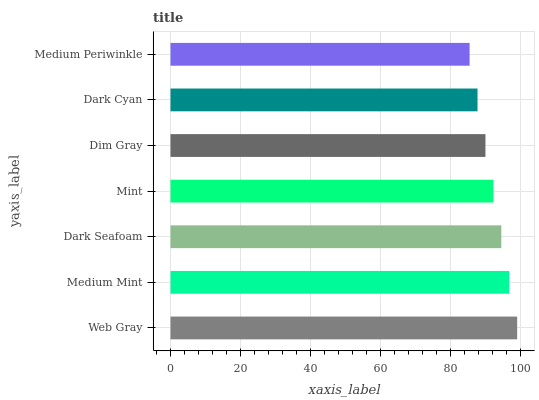Is Medium Periwinkle the minimum?
Answer yes or no. Yes. Is Web Gray the maximum?
Answer yes or no. Yes. Is Medium Mint the minimum?
Answer yes or no. No. Is Medium Mint the maximum?
Answer yes or no. No. Is Web Gray greater than Medium Mint?
Answer yes or no. Yes. Is Medium Mint less than Web Gray?
Answer yes or no. Yes. Is Medium Mint greater than Web Gray?
Answer yes or no. No. Is Web Gray less than Medium Mint?
Answer yes or no. No. Is Mint the high median?
Answer yes or no. Yes. Is Mint the low median?
Answer yes or no. Yes. Is Medium Mint the high median?
Answer yes or no. No. Is Dim Gray the low median?
Answer yes or no. No. 